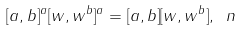<formula> <loc_0><loc_0><loc_500><loc_500>[ a , b ] ^ { a } [ w , w ^ { b } ] ^ { a } = [ a , b ] [ w , w ^ { b } ] , \ n</formula> 